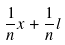Convert formula to latex. <formula><loc_0><loc_0><loc_500><loc_500>\frac { 1 } { n } x + \frac { 1 } { n } l</formula> 